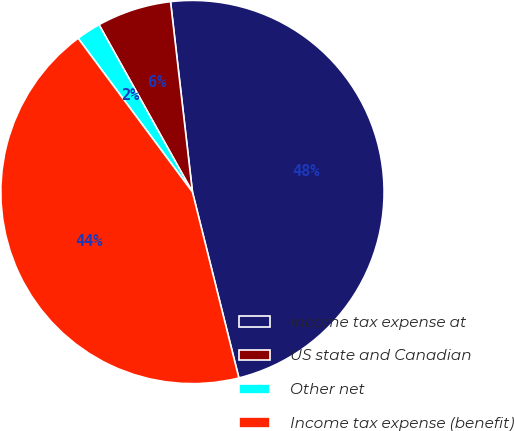Convert chart. <chart><loc_0><loc_0><loc_500><loc_500><pie_chart><fcel>Income tax expense at<fcel>US state and Canadian<fcel>Other net<fcel>Income tax expense (benefit)<nl><fcel>47.93%<fcel>6.28%<fcel>2.07%<fcel>43.72%<nl></chart> 